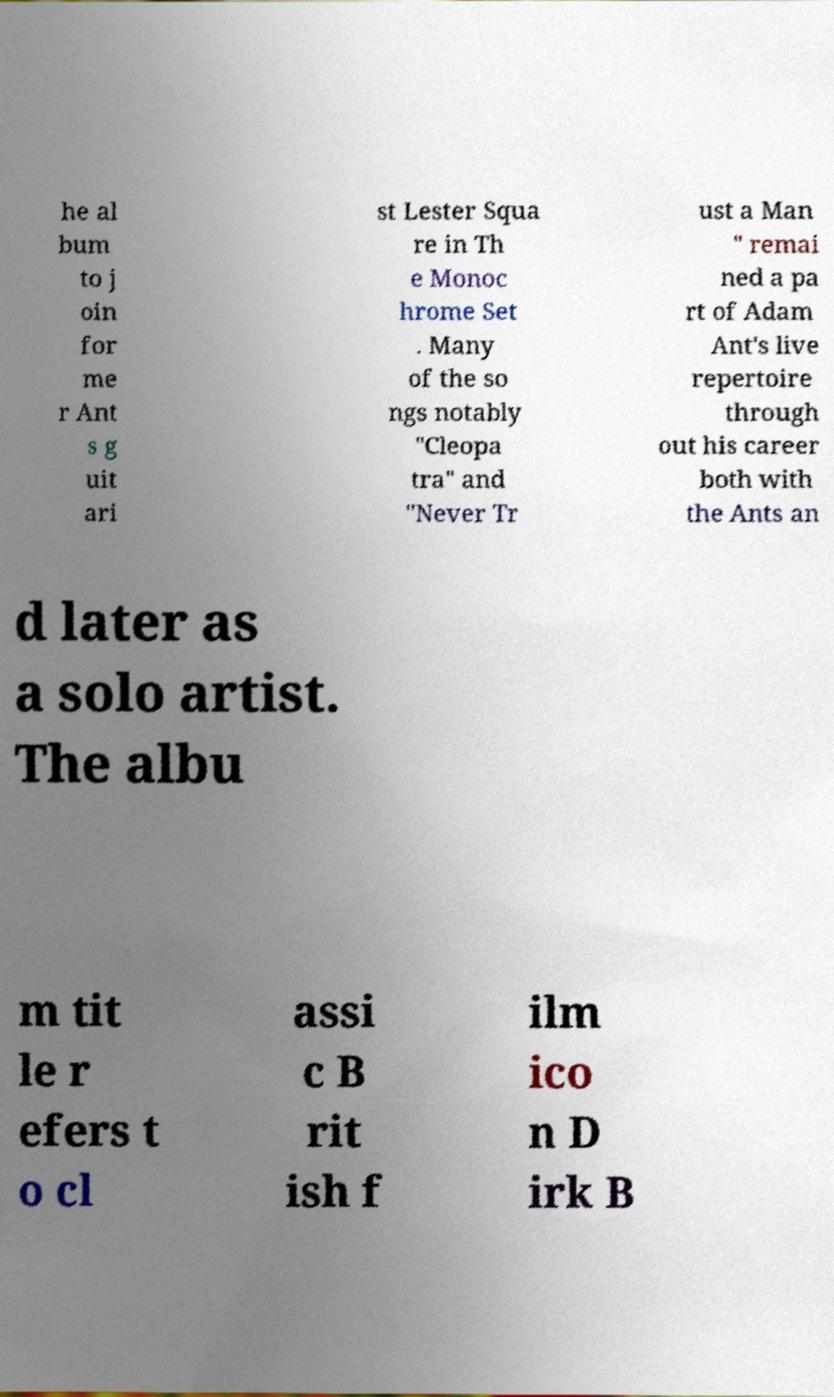There's text embedded in this image that I need extracted. Can you transcribe it verbatim? he al bum to j oin for me r Ant s g uit ari st Lester Squa re in Th e Monoc hrome Set . Many of the so ngs notably "Cleopa tra" and "Never Tr ust a Man " remai ned a pa rt of Adam Ant's live repertoire through out his career both with the Ants an d later as a solo artist. The albu m tit le r efers t o cl assi c B rit ish f ilm ico n D irk B 